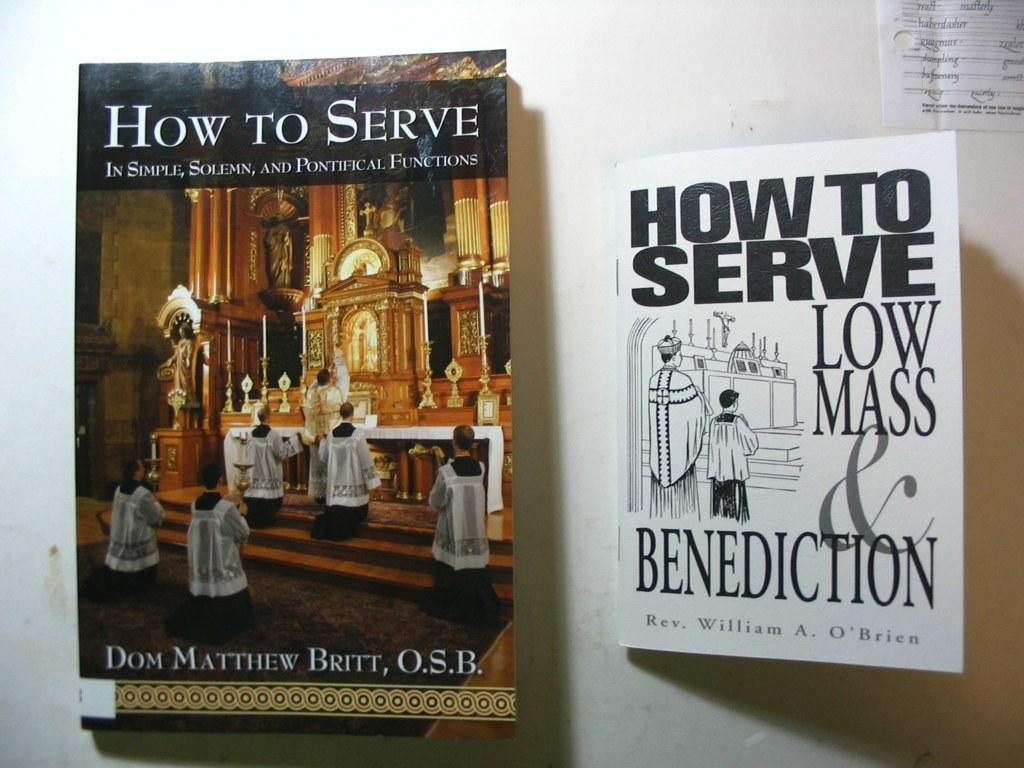<image>
Summarize the visual content of the image. Book with people at a Church altar titled "How to Serve". 